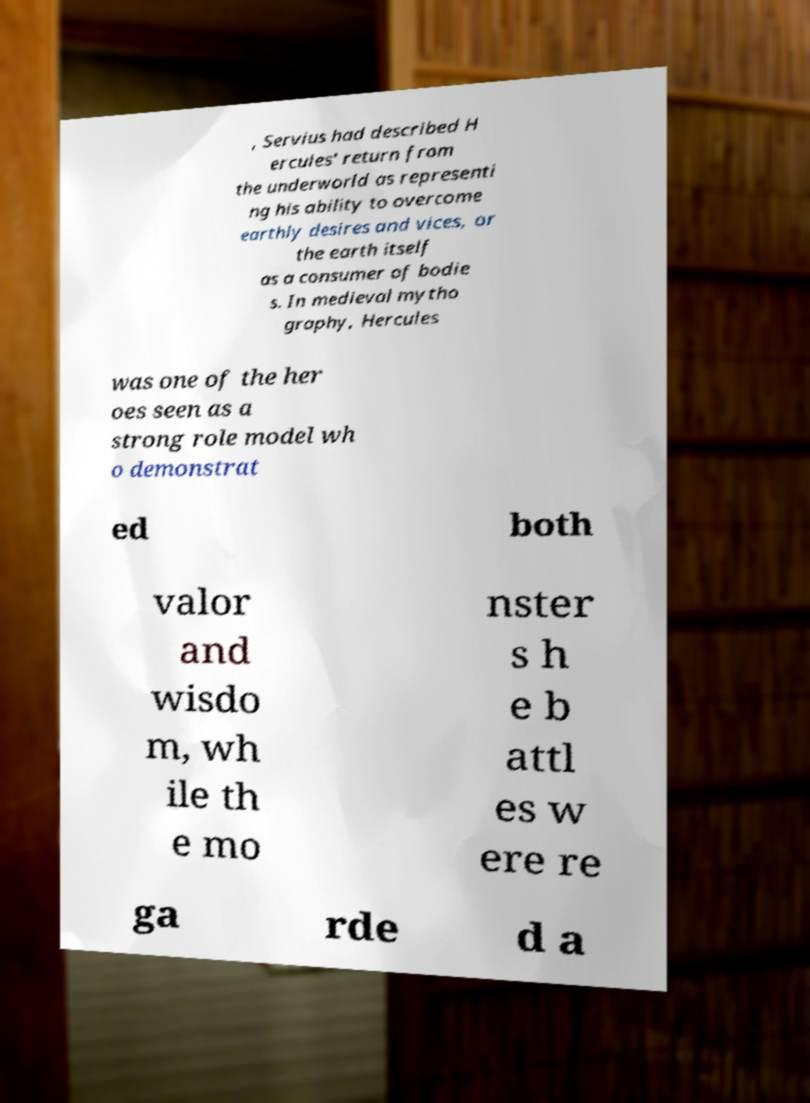Could you extract and type out the text from this image? , Servius had described H ercules' return from the underworld as representi ng his ability to overcome earthly desires and vices, or the earth itself as a consumer of bodie s. In medieval mytho graphy, Hercules was one of the her oes seen as a strong role model wh o demonstrat ed both valor and wisdo m, wh ile th e mo nster s h e b attl es w ere re ga rde d a 